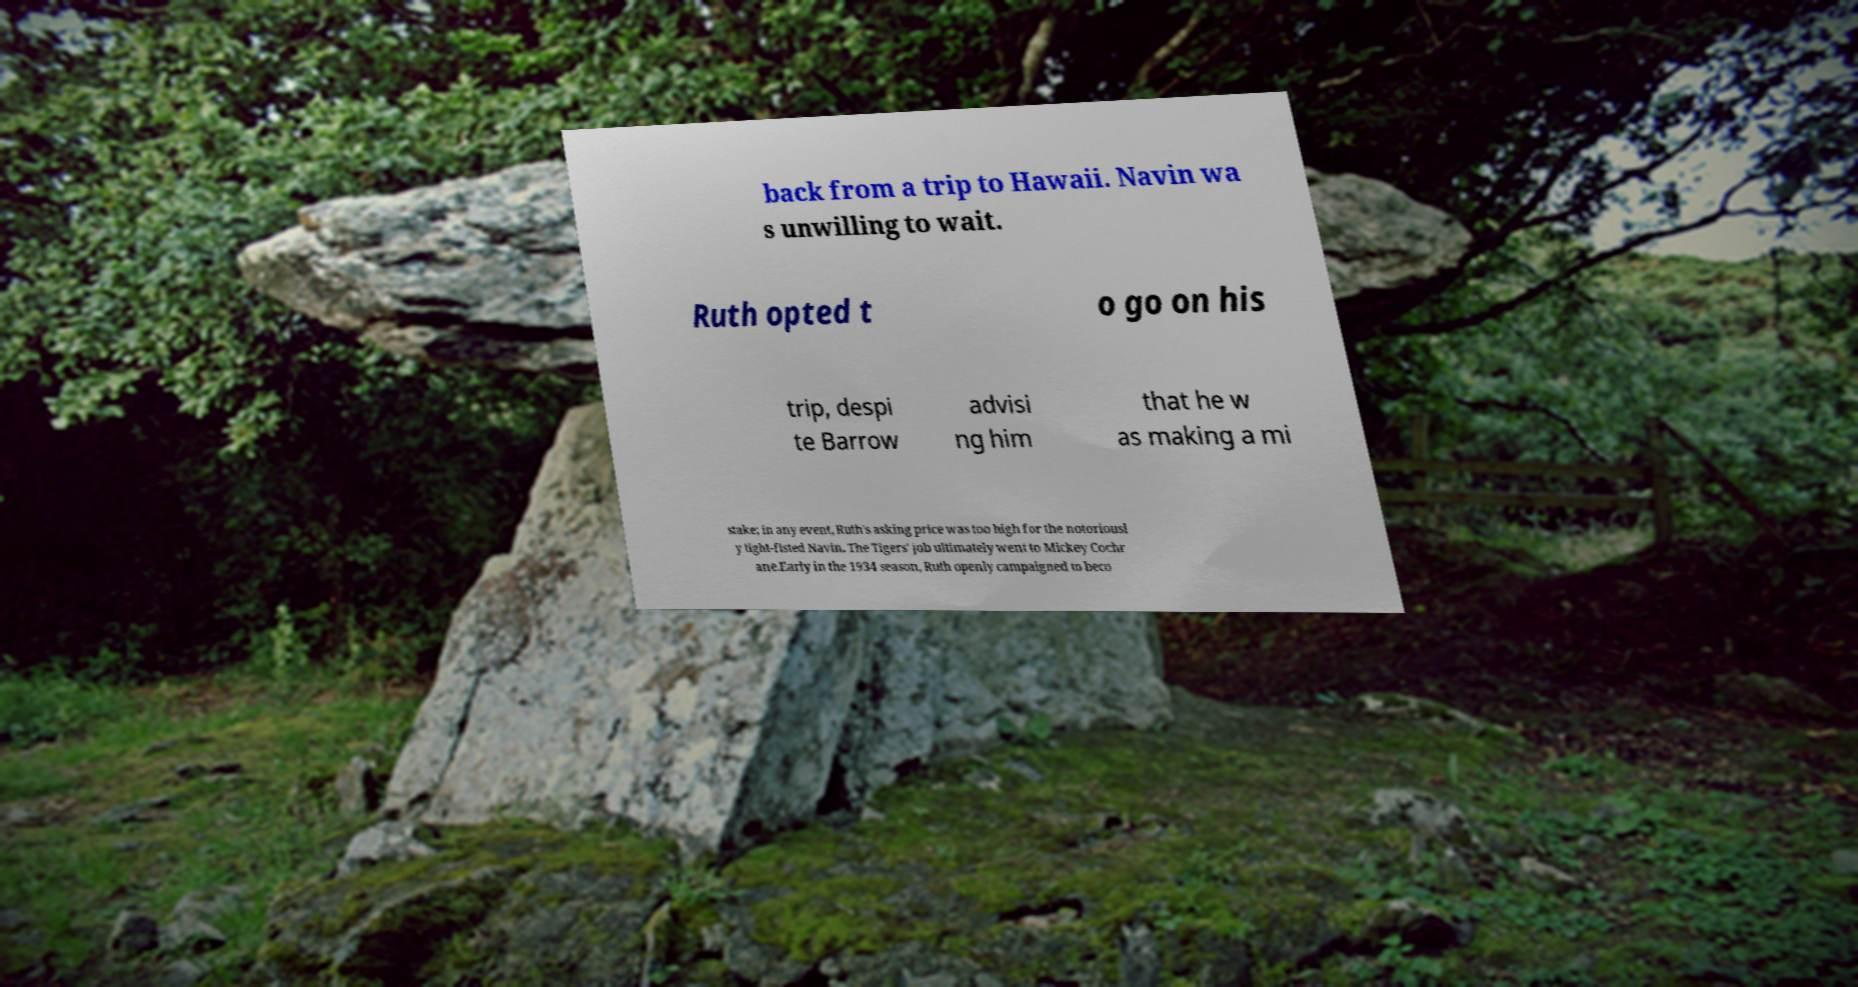Could you assist in decoding the text presented in this image and type it out clearly? back from a trip to Hawaii. Navin wa s unwilling to wait. Ruth opted t o go on his trip, despi te Barrow advisi ng him that he w as making a mi stake; in any event, Ruth's asking price was too high for the notoriousl y tight-fisted Navin. The Tigers' job ultimately went to Mickey Cochr ane.Early in the 1934 season, Ruth openly campaigned to beco 